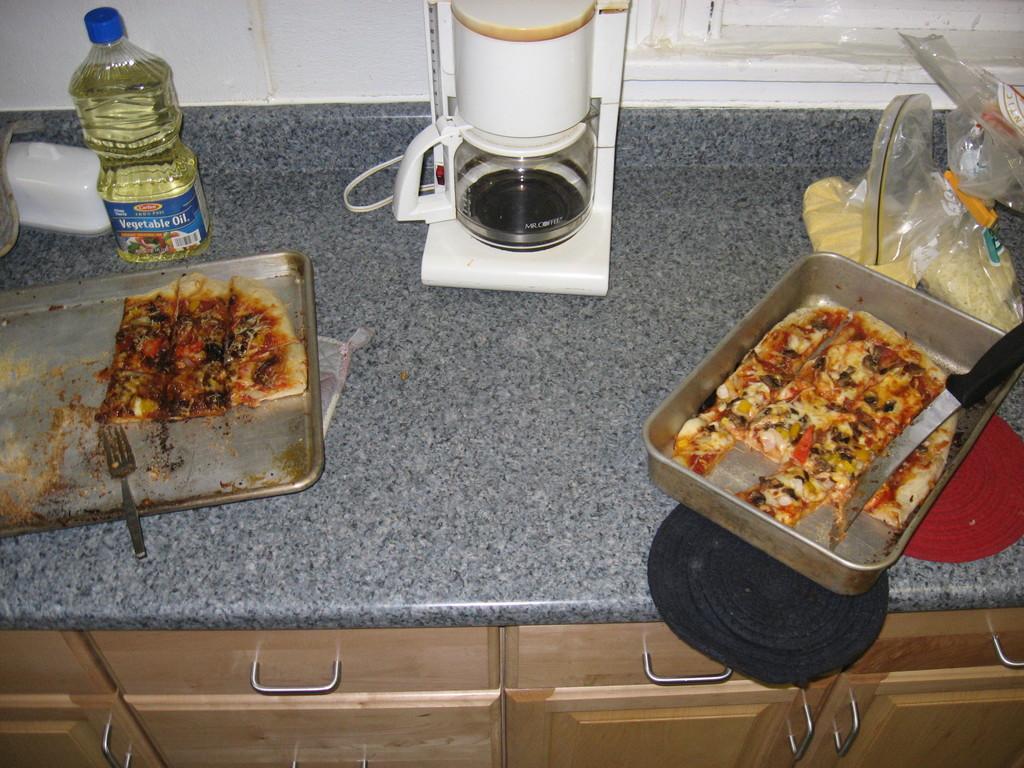What kind of oil is in the bottle?
Your answer should be very brief. Vegetable. 